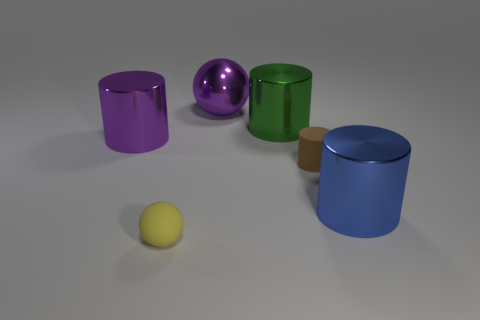Is the small brown object made of the same material as the large purple object on the right side of the large purple cylinder?
Provide a short and direct response. No. How big is the purple shiny ball?
Your answer should be compact. Large. What number of green rubber balls have the same size as the yellow matte thing?
Your answer should be very brief. 0. How many big green objects have the same shape as the small brown rubber thing?
Offer a very short reply. 1. Is the number of spheres that are in front of the big green cylinder the same as the number of big spheres?
Provide a succinct answer. Yes. What is the shape of the blue thing that is the same size as the green cylinder?
Make the answer very short. Cylinder. Is there a purple object that has the same shape as the brown object?
Provide a succinct answer. Yes. Is there a purple shiny object on the left side of the large cylinder on the right side of the tiny matte object behind the large blue object?
Your answer should be very brief. Yes. Are there more matte things right of the small yellow object than green cylinders to the right of the blue metal cylinder?
Ensure brevity in your answer.  Yes. What material is the yellow object that is the same size as the brown rubber cylinder?
Your response must be concise. Rubber. 